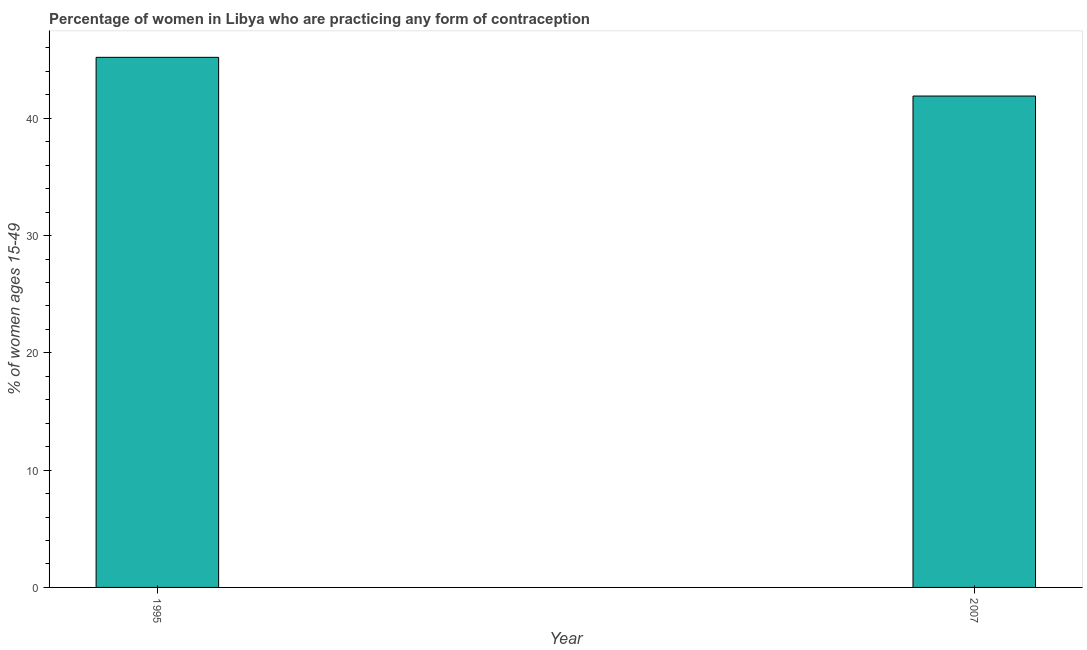Does the graph contain any zero values?
Your answer should be compact. No. Does the graph contain grids?
Your answer should be compact. No. What is the title of the graph?
Your response must be concise. Percentage of women in Libya who are practicing any form of contraception. What is the label or title of the X-axis?
Give a very brief answer. Year. What is the label or title of the Y-axis?
Keep it short and to the point. % of women ages 15-49. What is the contraceptive prevalence in 2007?
Keep it short and to the point. 41.9. Across all years, what is the maximum contraceptive prevalence?
Your response must be concise. 45.2. Across all years, what is the minimum contraceptive prevalence?
Provide a succinct answer. 41.9. In which year was the contraceptive prevalence maximum?
Provide a short and direct response. 1995. What is the sum of the contraceptive prevalence?
Ensure brevity in your answer.  87.1. What is the difference between the contraceptive prevalence in 1995 and 2007?
Your response must be concise. 3.3. What is the average contraceptive prevalence per year?
Provide a short and direct response. 43.55. What is the median contraceptive prevalence?
Provide a short and direct response. 43.55. Do a majority of the years between 1995 and 2007 (inclusive) have contraceptive prevalence greater than 20 %?
Make the answer very short. Yes. What is the ratio of the contraceptive prevalence in 1995 to that in 2007?
Offer a very short reply. 1.08. Is the contraceptive prevalence in 1995 less than that in 2007?
Offer a very short reply. No. In how many years, is the contraceptive prevalence greater than the average contraceptive prevalence taken over all years?
Make the answer very short. 1. Are the values on the major ticks of Y-axis written in scientific E-notation?
Ensure brevity in your answer.  No. What is the % of women ages 15-49 in 1995?
Your answer should be very brief. 45.2. What is the % of women ages 15-49 in 2007?
Your response must be concise. 41.9. What is the difference between the % of women ages 15-49 in 1995 and 2007?
Offer a terse response. 3.3. What is the ratio of the % of women ages 15-49 in 1995 to that in 2007?
Your response must be concise. 1.08. 